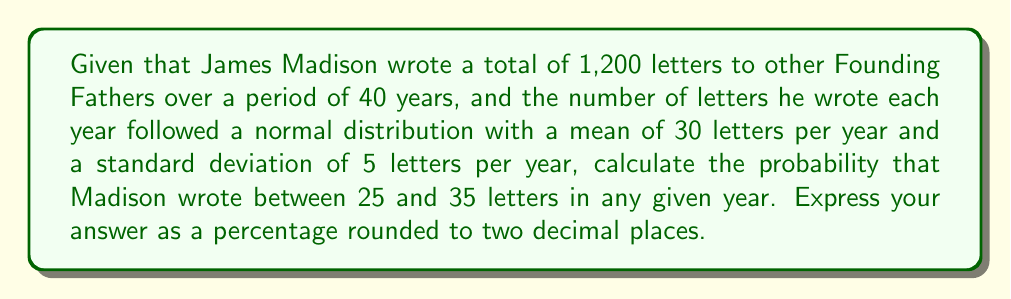Teach me how to tackle this problem. To solve this problem, we need to use the properties of the normal distribution and the concept of z-scores.

1. First, let's identify the given information:
   - Mean (μ) = 30 letters per year
   - Standard deviation (σ) = 5 letters per year
   - We want to find the probability of writing between 25 and 35 letters in a year

2. Calculate the z-scores for the lower and upper bounds:
   
   Lower bound: $z_1 = \frac{25 - 30}{5} = -1$
   
   Upper bound: $z_2 = \frac{35 - 30}{5} = 1$

3. Use the standard normal distribution table or a calculator to find the area under the curve between these z-scores.

4. The probability is equal to the area between z = -1 and z = 1 on the standard normal distribution.

5. For z = 1, the area to the left is approximately 0.8413
   For z = -1, the area to the left is approximately 0.1587

6. The probability we're looking for is the difference between these areas:
   
   $P(-1 < z < 1) = 0.8413 - 0.1587 = 0.6826$

7. Convert the probability to a percentage:
   
   $0.6826 \times 100\% = 68.26\%$

8. Round to two decimal places: 68.26%

This result indicates that in about 68.26% of the years, Madison would have written between 25 and 35 letters to other Founding Fathers, assuming the normal distribution model is accurate.
Answer: 68.26% 